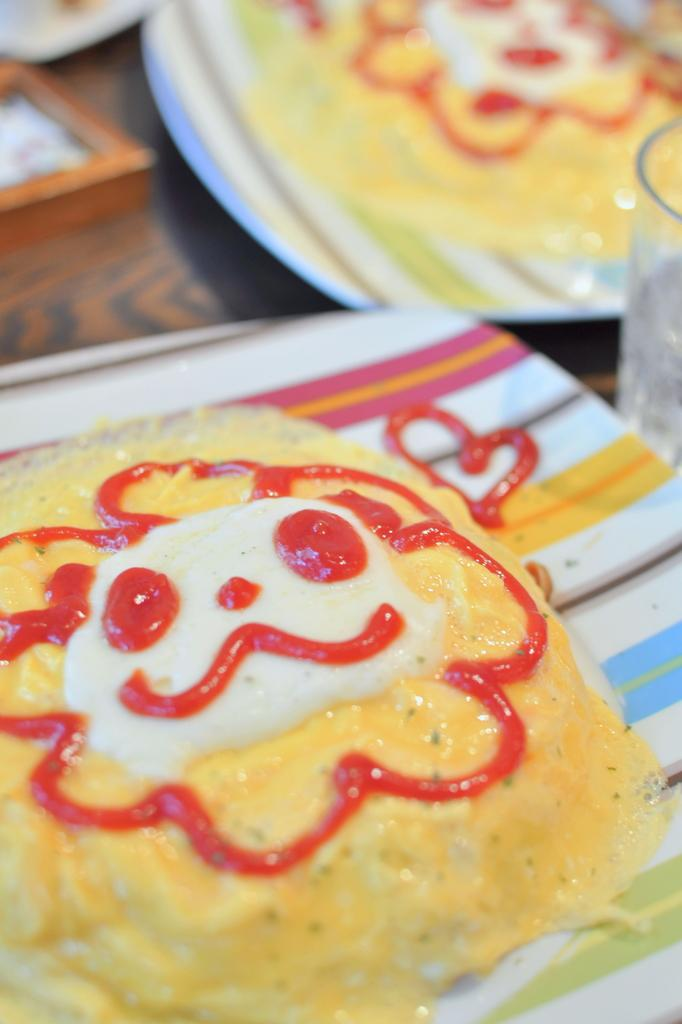What can be seen on the surface in the image? There are plates on a surface in the image. What is on the plates? There are food items on the plates. Can you describe the food items further? The food items have sauce on them, and there are other unspecified items on them. How does the quiet muscle powder affect the food items in the image? There is no mention of quiet muscle powder in the image, so it cannot be determined how it would affect the food items. 